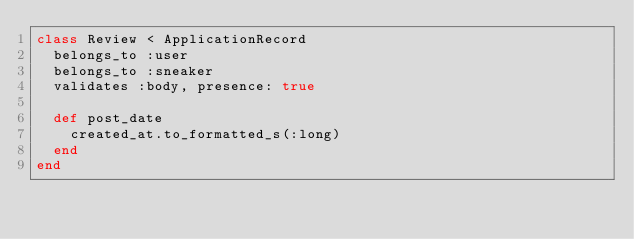Convert code to text. <code><loc_0><loc_0><loc_500><loc_500><_Ruby_>class Review < ApplicationRecord
  belongs_to :user
  belongs_to :sneaker
  validates :body, presence: true

  def post_date
    created_at.to_formatted_s(:long)
  end
end
</code> 